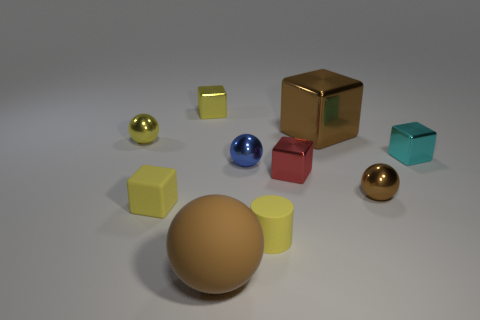Subtract all yellow blocks. How many blocks are left? 3 Subtract all yellow spheres. How many spheres are left? 3 Subtract all cylinders. How many objects are left? 9 Subtract 1 cylinders. How many cylinders are left? 0 Subtract all cyan cubes. How many green balls are left? 0 Subtract all yellow metal objects. Subtract all tiny objects. How many objects are left? 0 Add 2 large brown cubes. How many large brown cubes are left? 3 Add 5 yellow cylinders. How many yellow cylinders exist? 6 Subtract 0 blue cylinders. How many objects are left? 10 Subtract all blue spheres. Subtract all purple cylinders. How many spheres are left? 3 